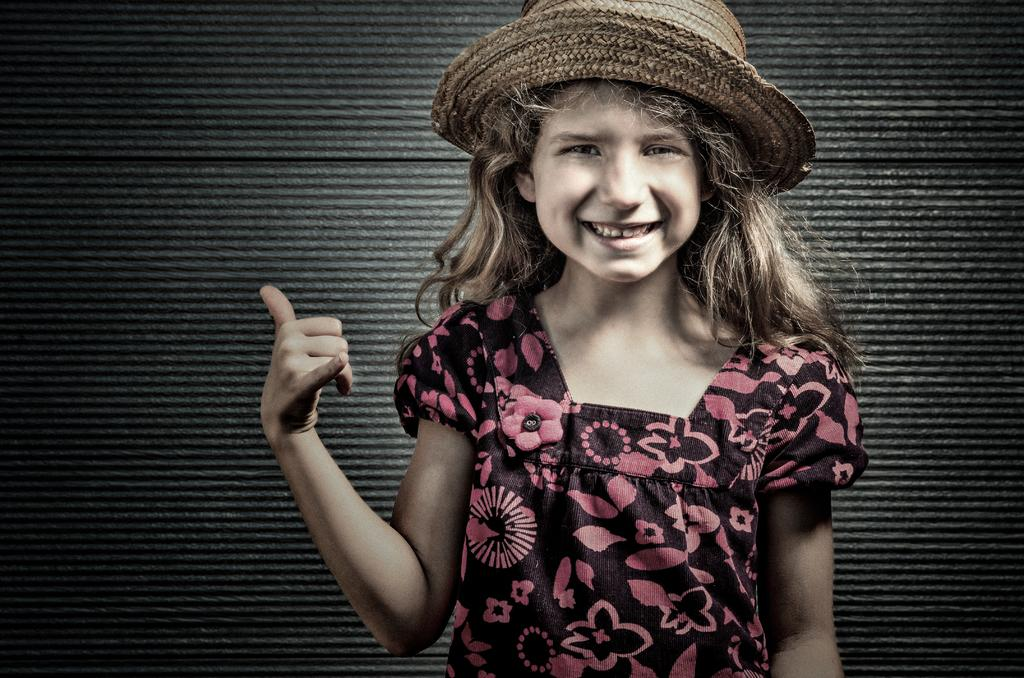Who is the main subject in the picture? There is a girl in the picture. What is the girl wearing on her head? The girl is wearing a hat. What is the girl's posture in the picture? The girl is standing. What is the girl's facial expression in the picture? The girl is smiling. What color is the crayon the girl is holding in the picture? There is no crayon present in the picture; the girl is not holding any crayons. Who is the girl's friend in the picture? There is no friend present in the picture; the girl is alone. 